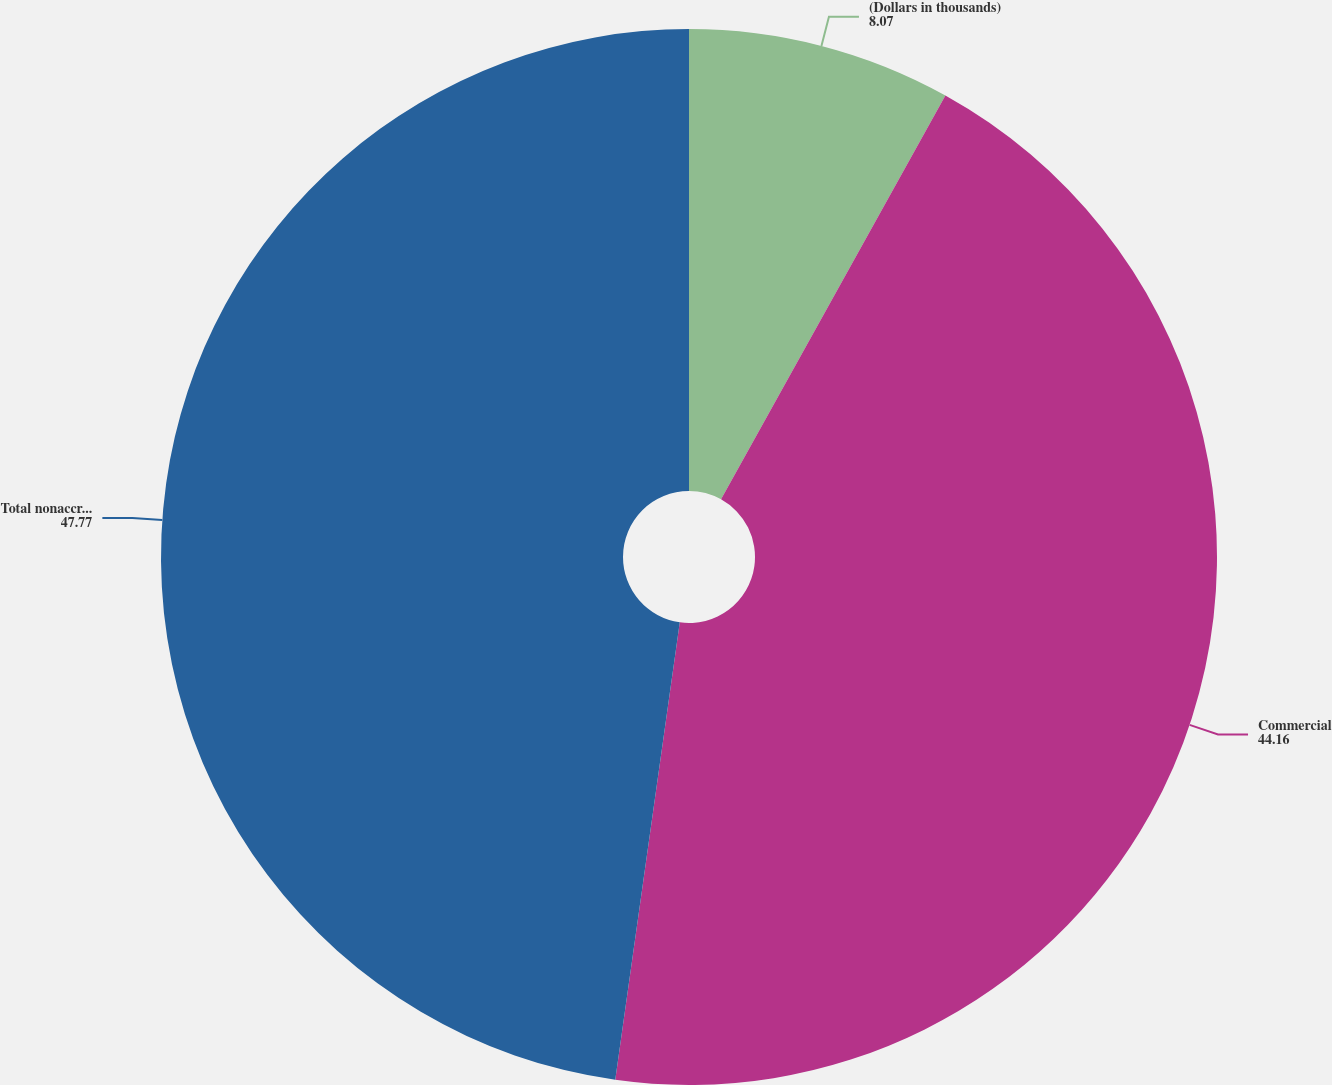Convert chart to OTSL. <chart><loc_0><loc_0><loc_500><loc_500><pie_chart><fcel>(Dollars in thousands)<fcel>Commercial<fcel>Total nonaccrual loans<nl><fcel>8.07%<fcel>44.16%<fcel>47.77%<nl></chart> 